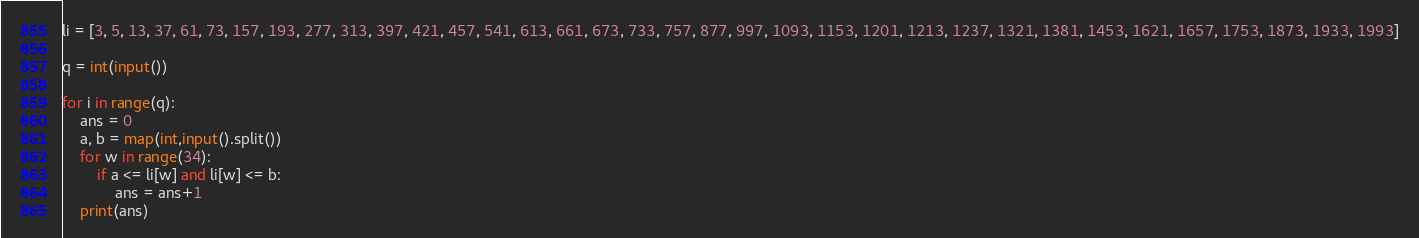Convert code to text. <code><loc_0><loc_0><loc_500><loc_500><_Python_>li = [3, 5, 13, 37, 61, 73, 157, 193, 277, 313, 397, 421, 457, 541, 613, 661, 673, 733, 757, 877, 997, 1093, 1153, 1201, 1213, 1237, 1321, 1381, 1453, 1621, 1657, 1753, 1873, 1933, 1993]

q = int(input())

for i in range(q):
	ans = 0
	a, b = map(int,input().split())
	for w in range(34):
		if a <= li[w] and li[w] <= b:
			ans = ans+1
	print(ans)</code> 